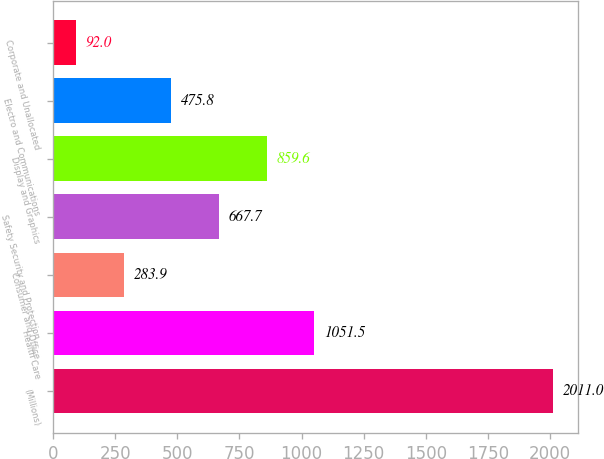<chart> <loc_0><loc_0><loc_500><loc_500><bar_chart><fcel>(Millions)<fcel>Health Care<fcel>Consumer and Office<fcel>Safety Security and Protection<fcel>Display and Graphics<fcel>Electro and Communications<fcel>Corporate and Unallocated<nl><fcel>2011<fcel>1051.5<fcel>283.9<fcel>667.7<fcel>859.6<fcel>475.8<fcel>92<nl></chart> 